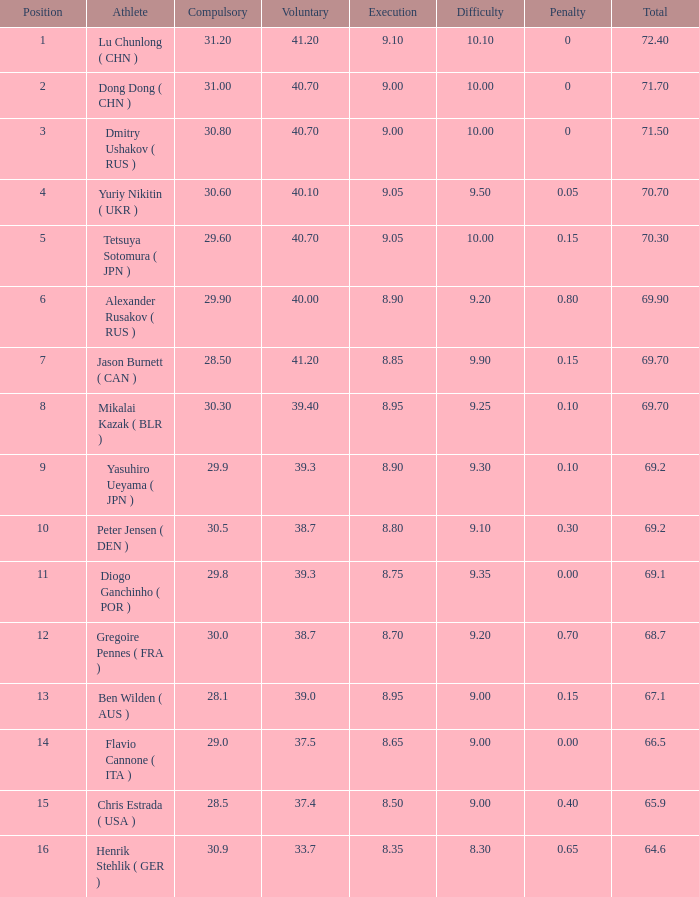What's the position that has a total less than 66.5m, a compulsory of 30.9 and voluntary less than 33.7? None. 